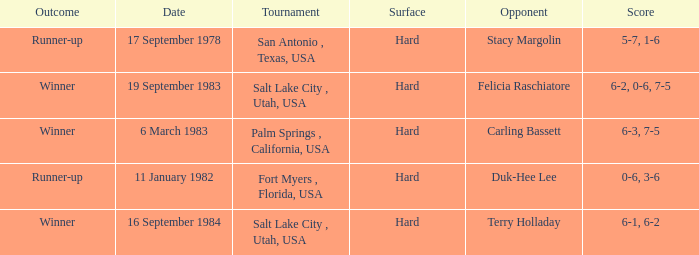What was the outcome of the match against Stacy Margolin? Runner-up. 